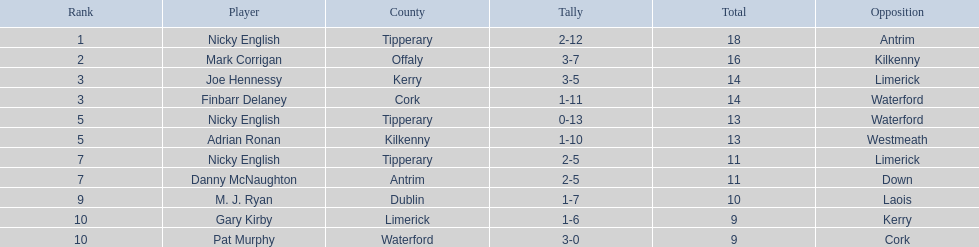How many instances was waterford the opposing side? 2. 